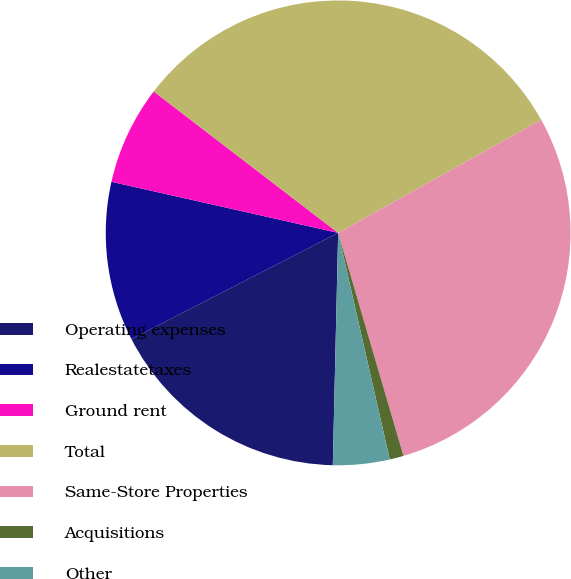Convert chart. <chart><loc_0><loc_0><loc_500><loc_500><pie_chart><fcel>Operating expenses<fcel>Realestatetaxes<fcel>Ground rent<fcel>Total<fcel>Same-Store Properties<fcel>Acquisitions<fcel>Other<nl><fcel>17.08%<fcel>11.08%<fcel>6.88%<fcel>31.5%<fcel>28.55%<fcel>0.97%<fcel>3.93%<nl></chart> 